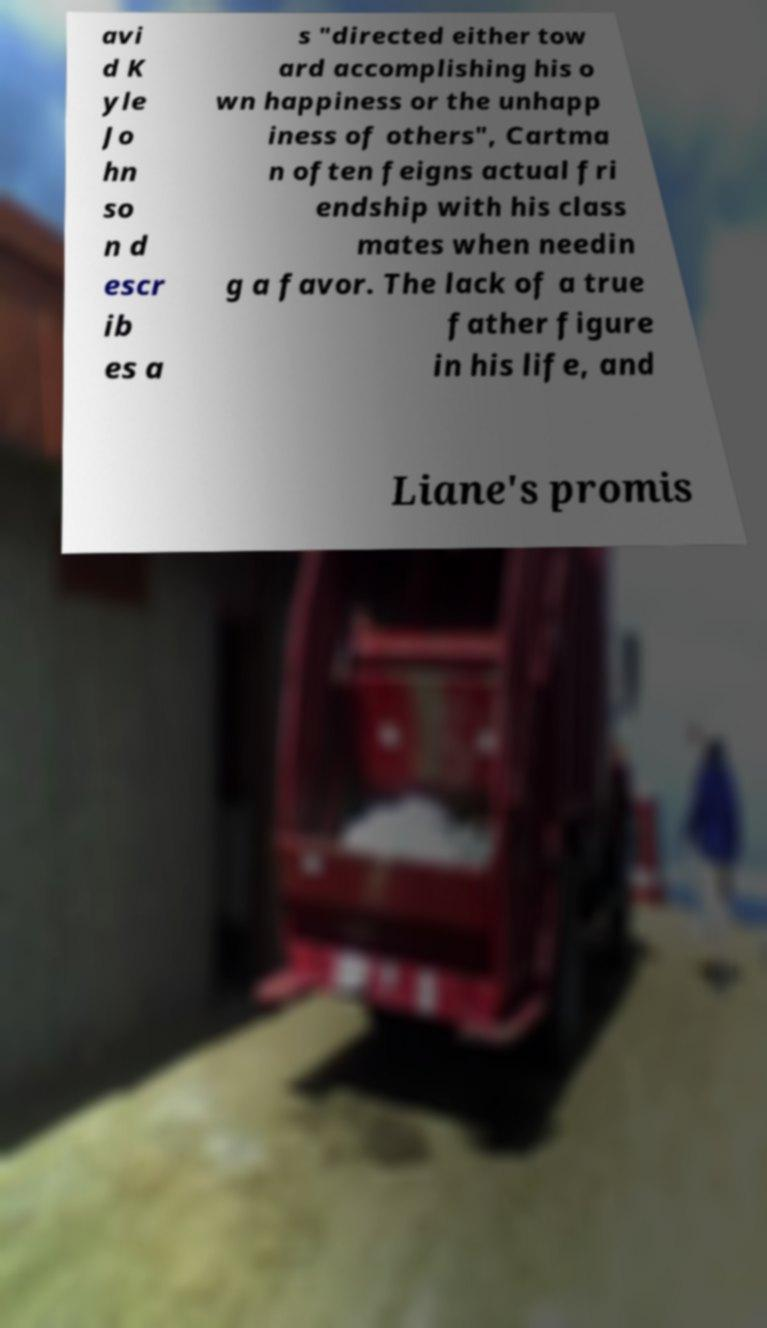Could you extract and type out the text from this image? avi d K yle Jo hn so n d escr ib es a s "directed either tow ard accomplishing his o wn happiness or the unhapp iness of others", Cartma n often feigns actual fri endship with his class mates when needin g a favor. The lack of a true father figure in his life, and Liane's promis 